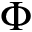<formula> <loc_0><loc_0><loc_500><loc_500>{ \Phi }</formula> 